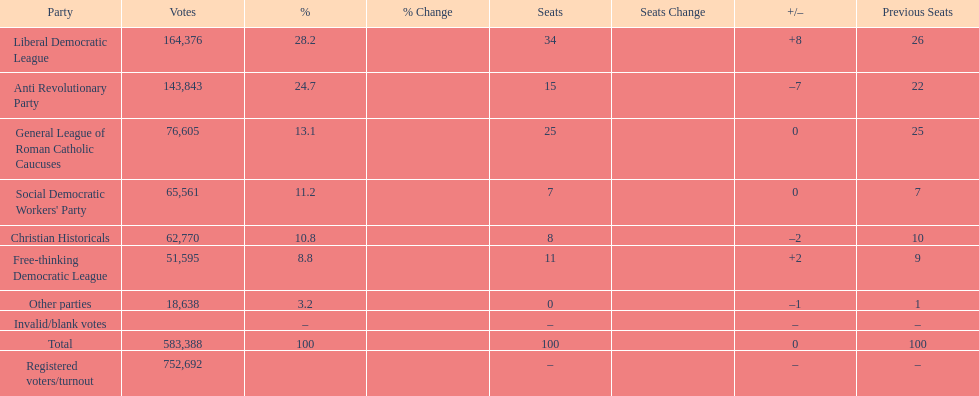Name the top three parties? Liberal Democratic League, Anti Revolutionary Party, General League of Roman Catholic Caucuses. 